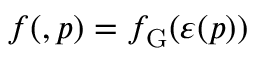Convert formula to latex. <formula><loc_0><loc_0><loc_500><loc_500>f ( \ v { r } , \ v { p } ) = f _ { G } ( \varepsilon ( \ v { p } ) )</formula> 